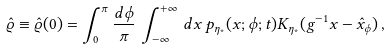Convert formula to latex. <formula><loc_0><loc_0><loc_500><loc_500>\hat { \varrho } \equiv \hat { \varrho } ( 0 ) = \int ^ { \pi } _ { 0 } \frac { d \phi } { \pi } \, \int ^ { + \infty } _ { - \infty } \, d x \, p _ { \eta _ { * } } ( x ; \phi ; t ) K _ { \eta _ { * } } ( g ^ { - 1 } x - \hat { x } _ { \phi } ) \, ,</formula> 